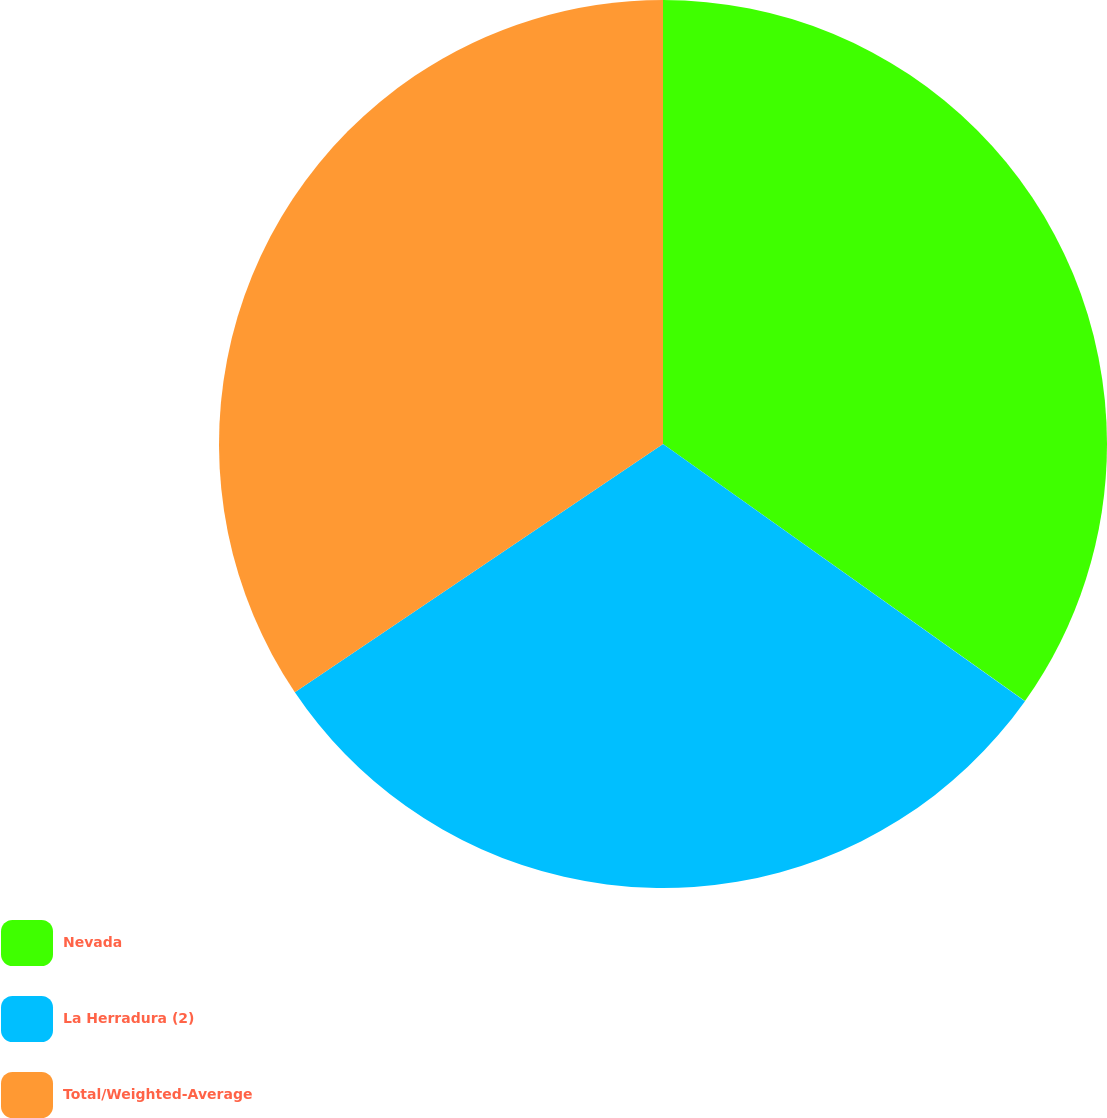Convert chart to OTSL. <chart><loc_0><loc_0><loc_500><loc_500><pie_chart><fcel>Nevada<fcel>La Herradura (2)<fcel>Total/Weighted-Average<nl><fcel>34.83%<fcel>30.73%<fcel>34.44%<nl></chart> 